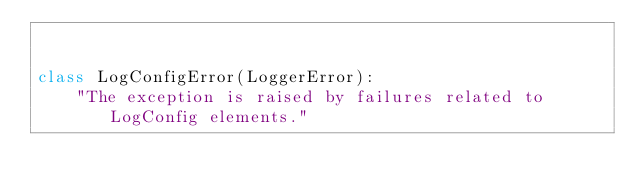Convert code to text. <code><loc_0><loc_0><loc_500><loc_500><_Python_>

class LogConfigError(LoggerError):
    "The exception is raised by failures related to LogConfig elements."
</code> 